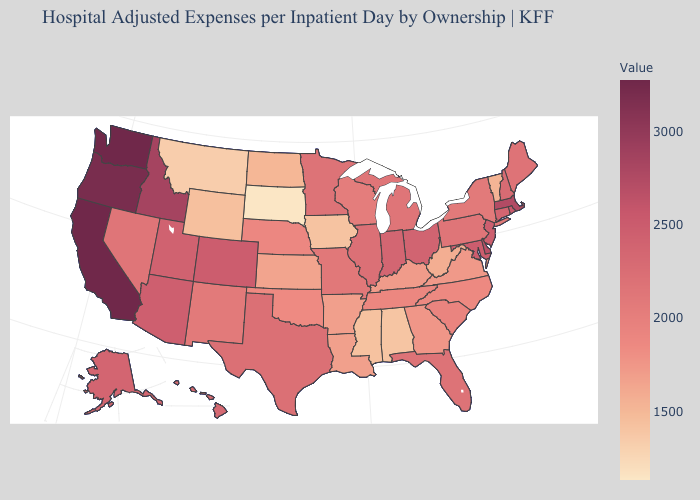Does the map have missing data?
Concise answer only. No. Does Missouri have a lower value than Arkansas?
Answer briefly. No. Is the legend a continuous bar?
Give a very brief answer. Yes. Does New York have a higher value than Delaware?
Be succinct. No. Which states have the lowest value in the MidWest?
Give a very brief answer. South Dakota. Among the states that border New Mexico , which have the lowest value?
Answer briefly. Oklahoma. Among the states that border New Jersey , does Pennsylvania have the lowest value?
Concise answer only. No. Does California have the highest value in the USA?
Give a very brief answer. Yes. Which states have the highest value in the USA?
Be succinct. California. 